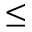Convert formula to latex. <formula><loc_0><loc_0><loc_500><loc_500>\leq</formula> 